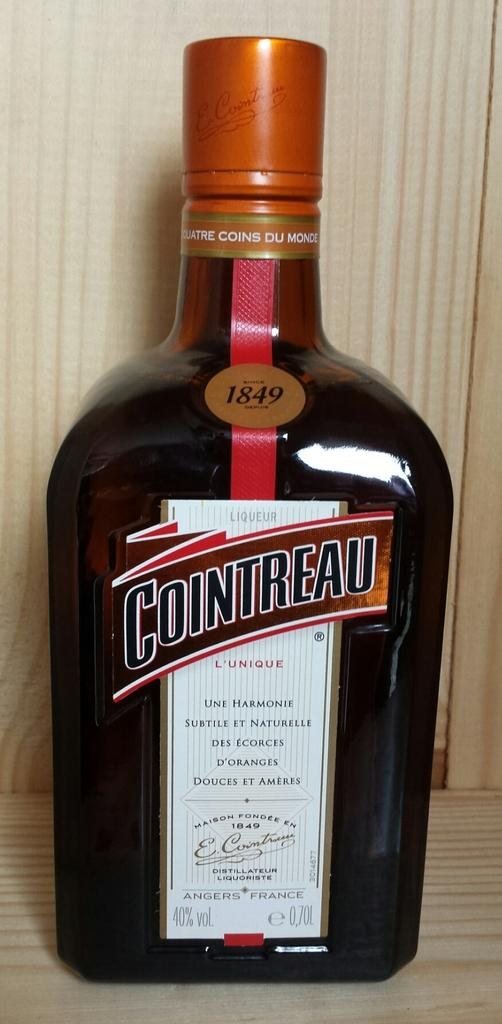Provide a one-sentence caption for the provided image. A sealed .70L bottle of 1849 Cointreau liquor. 